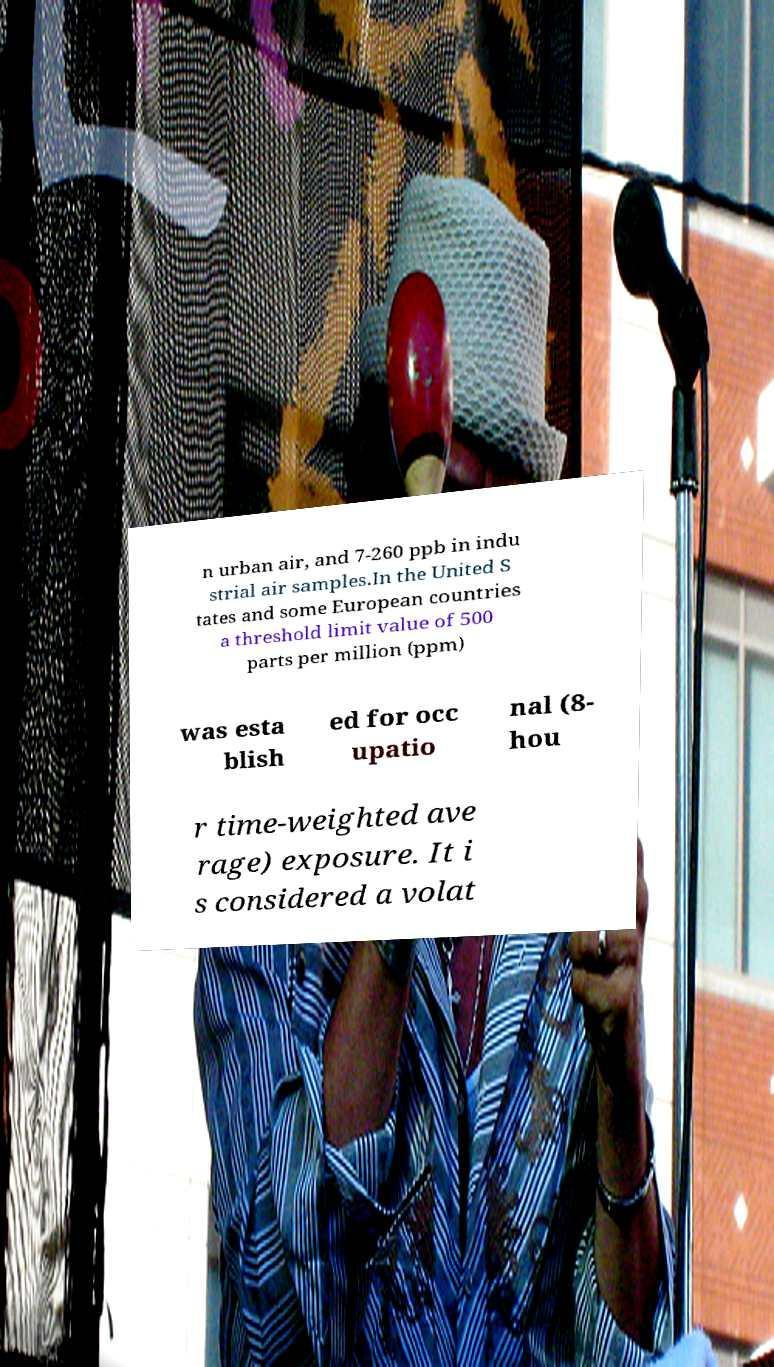Please identify and transcribe the text found in this image. n urban air, and 7-260 ppb in indu strial air samples.In the United S tates and some European countries a threshold limit value of 500 parts per million (ppm) was esta blish ed for occ upatio nal (8- hou r time-weighted ave rage) exposure. It i s considered a volat 